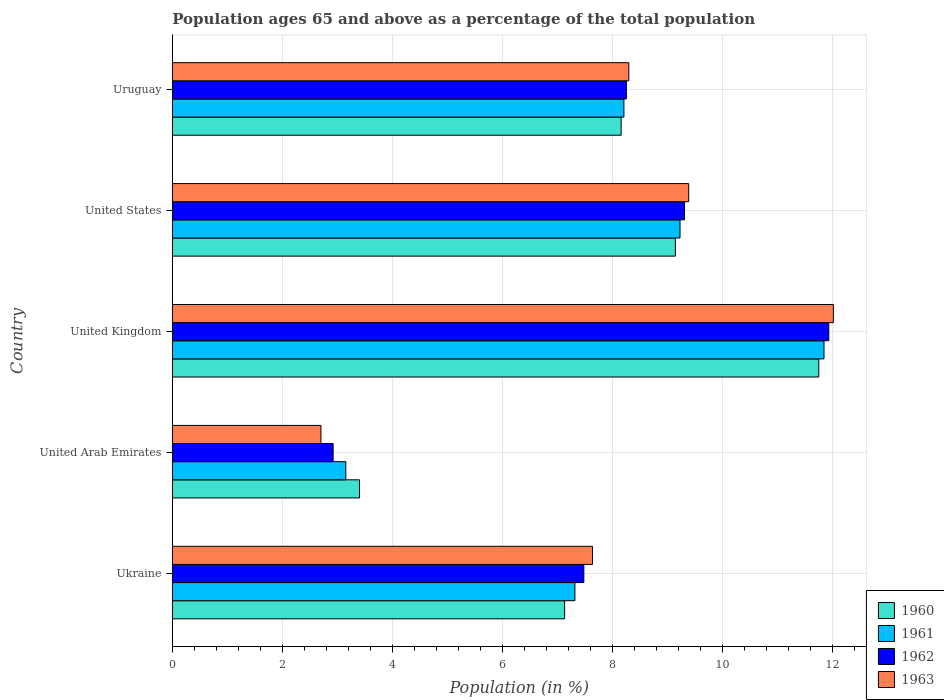How many bars are there on the 1st tick from the top?
Offer a very short reply. 4. What is the label of the 4th group of bars from the top?
Give a very brief answer. United Arab Emirates. In how many cases, is the number of bars for a given country not equal to the number of legend labels?
Your response must be concise. 0. What is the percentage of the population ages 65 and above in 1963 in United States?
Offer a terse response. 9.39. Across all countries, what is the maximum percentage of the population ages 65 and above in 1962?
Your response must be concise. 11.94. Across all countries, what is the minimum percentage of the population ages 65 and above in 1962?
Your answer should be very brief. 2.92. In which country was the percentage of the population ages 65 and above in 1961 minimum?
Keep it short and to the point. United Arab Emirates. What is the total percentage of the population ages 65 and above in 1963 in the graph?
Your answer should be very brief. 40.05. What is the difference between the percentage of the population ages 65 and above in 1962 in Ukraine and that in Uruguay?
Provide a short and direct response. -0.77. What is the difference between the percentage of the population ages 65 and above in 1961 in United States and the percentage of the population ages 65 and above in 1960 in Uruguay?
Your answer should be compact. 1.07. What is the average percentage of the population ages 65 and above in 1960 per country?
Your response must be concise. 7.92. What is the difference between the percentage of the population ages 65 and above in 1961 and percentage of the population ages 65 and above in 1962 in United States?
Provide a succinct answer. -0.08. What is the ratio of the percentage of the population ages 65 and above in 1960 in Ukraine to that in Uruguay?
Offer a very short reply. 0.87. Is the difference between the percentage of the population ages 65 and above in 1961 in Ukraine and United States greater than the difference between the percentage of the population ages 65 and above in 1962 in Ukraine and United States?
Your response must be concise. No. What is the difference between the highest and the second highest percentage of the population ages 65 and above in 1960?
Ensure brevity in your answer.  2.61. What is the difference between the highest and the lowest percentage of the population ages 65 and above in 1962?
Give a very brief answer. 9.01. What does the 1st bar from the bottom in United States represents?
Offer a very short reply. 1960. Is it the case that in every country, the sum of the percentage of the population ages 65 and above in 1963 and percentage of the population ages 65 and above in 1961 is greater than the percentage of the population ages 65 and above in 1960?
Ensure brevity in your answer.  Yes. How many countries are there in the graph?
Give a very brief answer. 5. Does the graph contain any zero values?
Your response must be concise. No. Where does the legend appear in the graph?
Your response must be concise. Bottom right. How many legend labels are there?
Give a very brief answer. 4. How are the legend labels stacked?
Offer a very short reply. Vertical. What is the title of the graph?
Your response must be concise. Population ages 65 and above as a percentage of the total population. What is the label or title of the Y-axis?
Provide a succinct answer. Country. What is the Population (in %) of 1960 in Ukraine?
Provide a short and direct response. 7.13. What is the Population (in %) of 1961 in Ukraine?
Offer a terse response. 7.32. What is the Population (in %) of 1962 in Ukraine?
Your response must be concise. 7.48. What is the Population (in %) in 1963 in Ukraine?
Give a very brief answer. 7.64. What is the Population (in %) of 1960 in United Arab Emirates?
Your answer should be compact. 3.4. What is the Population (in %) in 1961 in United Arab Emirates?
Give a very brief answer. 3.15. What is the Population (in %) in 1962 in United Arab Emirates?
Your answer should be compact. 2.92. What is the Population (in %) in 1963 in United Arab Emirates?
Make the answer very short. 2.7. What is the Population (in %) of 1960 in United Kingdom?
Your response must be concise. 11.75. What is the Population (in %) of 1961 in United Kingdom?
Provide a succinct answer. 11.85. What is the Population (in %) in 1962 in United Kingdom?
Provide a short and direct response. 11.94. What is the Population (in %) of 1963 in United Kingdom?
Your answer should be compact. 12.02. What is the Population (in %) in 1960 in United States?
Your answer should be very brief. 9.15. What is the Population (in %) in 1961 in United States?
Your answer should be compact. 9.23. What is the Population (in %) in 1962 in United States?
Offer a very short reply. 9.31. What is the Population (in %) of 1963 in United States?
Your response must be concise. 9.39. What is the Population (in %) in 1960 in Uruguay?
Your answer should be compact. 8.16. What is the Population (in %) of 1961 in Uruguay?
Keep it short and to the point. 8.21. What is the Population (in %) of 1962 in Uruguay?
Ensure brevity in your answer.  8.26. What is the Population (in %) in 1963 in Uruguay?
Provide a short and direct response. 8.3. Across all countries, what is the maximum Population (in %) in 1960?
Offer a very short reply. 11.75. Across all countries, what is the maximum Population (in %) of 1961?
Ensure brevity in your answer.  11.85. Across all countries, what is the maximum Population (in %) in 1962?
Your answer should be very brief. 11.94. Across all countries, what is the maximum Population (in %) of 1963?
Keep it short and to the point. 12.02. Across all countries, what is the minimum Population (in %) of 1960?
Provide a succinct answer. 3.4. Across all countries, what is the minimum Population (in %) in 1961?
Offer a very short reply. 3.15. Across all countries, what is the minimum Population (in %) of 1962?
Provide a short and direct response. 2.92. Across all countries, what is the minimum Population (in %) of 1963?
Give a very brief answer. 2.7. What is the total Population (in %) in 1960 in the graph?
Make the answer very short. 39.6. What is the total Population (in %) in 1961 in the graph?
Ensure brevity in your answer.  39.76. What is the total Population (in %) of 1962 in the graph?
Offer a terse response. 39.91. What is the total Population (in %) of 1963 in the graph?
Offer a very short reply. 40.05. What is the difference between the Population (in %) in 1960 in Ukraine and that in United Arab Emirates?
Your response must be concise. 3.73. What is the difference between the Population (in %) in 1961 in Ukraine and that in United Arab Emirates?
Ensure brevity in your answer.  4.17. What is the difference between the Population (in %) in 1962 in Ukraine and that in United Arab Emirates?
Provide a short and direct response. 4.56. What is the difference between the Population (in %) of 1963 in Ukraine and that in United Arab Emirates?
Provide a succinct answer. 4.94. What is the difference between the Population (in %) of 1960 in Ukraine and that in United Kingdom?
Your response must be concise. -4.62. What is the difference between the Population (in %) in 1961 in Ukraine and that in United Kingdom?
Provide a short and direct response. -4.53. What is the difference between the Population (in %) in 1962 in Ukraine and that in United Kingdom?
Keep it short and to the point. -4.45. What is the difference between the Population (in %) in 1963 in Ukraine and that in United Kingdom?
Give a very brief answer. -4.38. What is the difference between the Population (in %) of 1960 in Ukraine and that in United States?
Provide a succinct answer. -2.01. What is the difference between the Population (in %) in 1961 in Ukraine and that in United States?
Your answer should be very brief. -1.91. What is the difference between the Population (in %) in 1962 in Ukraine and that in United States?
Make the answer very short. -1.83. What is the difference between the Population (in %) in 1963 in Ukraine and that in United States?
Make the answer very short. -1.75. What is the difference between the Population (in %) in 1960 in Ukraine and that in Uruguay?
Provide a succinct answer. -1.03. What is the difference between the Population (in %) in 1961 in Ukraine and that in Uruguay?
Make the answer very short. -0.89. What is the difference between the Population (in %) of 1962 in Ukraine and that in Uruguay?
Your response must be concise. -0.77. What is the difference between the Population (in %) of 1963 in Ukraine and that in Uruguay?
Your response must be concise. -0.66. What is the difference between the Population (in %) of 1960 in United Arab Emirates and that in United Kingdom?
Offer a very short reply. -8.35. What is the difference between the Population (in %) in 1961 in United Arab Emirates and that in United Kingdom?
Ensure brevity in your answer.  -8.69. What is the difference between the Population (in %) in 1962 in United Arab Emirates and that in United Kingdom?
Offer a very short reply. -9.01. What is the difference between the Population (in %) of 1963 in United Arab Emirates and that in United Kingdom?
Offer a very short reply. -9.32. What is the difference between the Population (in %) of 1960 in United Arab Emirates and that in United States?
Give a very brief answer. -5.74. What is the difference between the Population (in %) in 1961 in United Arab Emirates and that in United States?
Provide a succinct answer. -6.08. What is the difference between the Population (in %) in 1962 in United Arab Emirates and that in United States?
Your answer should be compact. -6.39. What is the difference between the Population (in %) of 1963 in United Arab Emirates and that in United States?
Offer a very short reply. -6.69. What is the difference between the Population (in %) in 1960 in United Arab Emirates and that in Uruguay?
Keep it short and to the point. -4.76. What is the difference between the Population (in %) in 1961 in United Arab Emirates and that in Uruguay?
Make the answer very short. -5.06. What is the difference between the Population (in %) in 1962 in United Arab Emirates and that in Uruguay?
Give a very brief answer. -5.33. What is the difference between the Population (in %) of 1963 in United Arab Emirates and that in Uruguay?
Your answer should be compact. -5.6. What is the difference between the Population (in %) in 1960 in United Kingdom and that in United States?
Your response must be concise. 2.61. What is the difference between the Population (in %) in 1961 in United Kingdom and that in United States?
Your response must be concise. 2.62. What is the difference between the Population (in %) in 1962 in United Kingdom and that in United States?
Offer a terse response. 2.62. What is the difference between the Population (in %) in 1963 in United Kingdom and that in United States?
Provide a short and direct response. 2.63. What is the difference between the Population (in %) in 1960 in United Kingdom and that in Uruguay?
Ensure brevity in your answer.  3.59. What is the difference between the Population (in %) of 1961 in United Kingdom and that in Uruguay?
Keep it short and to the point. 3.64. What is the difference between the Population (in %) of 1962 in United Kingdom and that in Uruguay?
Give a very brief answer. 3.68. What is the difference between the Population (in %) in 1963 in United Kingdom and that in Uruguay?
Offer a very short reply. 3.72. What is the difference between the Population (in %) of 1960 in United States and that in Uruguay?
Your response must be concise. 0.99. What is the difference between the Population (in %) in 1961 in United States and that in Uruguay?
Offer a terse response. 1.02. What is the difference between the Population (in %) in 1962 in United States and that in Uruguay?
Your response must be concise. 1.06. What is the difference between the Population (in %) in 1963 in United States and that in Uruguay?
Your answer should be very brief. 1.09. What is the difference between the Population (in %) in 1960 in Ukraine and the Population (in %) in 1961 in United Arab Emirates?
Your answer should be compact. 3.98. What is the difference between the Population (in %) of 1960 in Ukraine and the Population (in %) of 1962 in United Arab Emirates?
Your response must be concise. 4.21. What is the difference between the Population (in %) in 1960 in Ukraine and the Population (in %) in 1963 in United Arab Emirates?
Offer a terse response. 4.43. What is the difference between the Population (in %) of 1961 in Ukraine and the Population (in %) of 1962 in United Arab Emirates?
Provide a short and direct response. 4.4. What is the difference between the Population (in %) in 1961 in Ukraine and the Population (in %) in 1963 in United Arab Emirates?
Ensure brevity in your answer.  4.62. What is the difference between the Population (in %) of 1962 in Ukraine and the Population (in %) of 1963 in United Arab Emirates?
Your response must be concise. 4.78. What is the difference between the Population (in %) in 1960 in Ukraine and the Population (in %) in 1961 in United Kingdom?
Your answer should be compact. -4.72. What is the difference between the Population (in %) of 1960 in Ukraine and the Population (in %) of 1962 in United Kingdom?
Make the answer very short. -4.8. What is the difference between the Population (in %) of 1960 in Ukraine and the Population (in %) of 1963 in United Kingdom?
Make the answer very short. -4.89. What is the difference between the Population (in %) of 1961 in Ukraine and the Population (in %) of 1962 in United Kingdom?
Keep it short and to the point. -4.62. What is the difference between the Population (in %) of 1961 in Ukraine and the Population (in %) of 1963 in United Kingdom?
Offer a very short reply. -4.7. What is the difference between the Population (in %) in 1962 in Ukraine and the Population (in %) in 1963 in United Kingdom?
Your response must be concise. -4.54. What is the difference between the Population (in %) in 1960 in Ukraine and the Population (in %) in 1961 in United States?
Your answer should be very brief. -2.1. What is the difference between the Population (in %) of 1960 in Ukraine and the Population (in %) of 1962 in United States?
Offer a terse response. -2.18. What is the difference between the Population (in %) in 1960 in Ukraine and the Population (in %) in 1963 in United States?
Your answer should be compact. -2.26. What is the difference between the Population (in %) in 1961 in Ukraine and the Population (in %) in 1962 in United States?
Your answer should be very brief. -1.99. What is the difference between the Population (in %) of 1961 in Ukraine and the Population (in %) of 1963 in United States?
Keep it short and to the point. -2.07. What is the difference between the Population (in %) of 1962 in Ukraine and the Population (in %) of 1963 in United States?
Provide a short and direct response. -1.91. What is the difference between the Population (in %) of 1960 in Ukraine and the Population (in %) of 1961 in Uruguay?
Your answer should be compact. -1.08. What is the difference between the Population (in %) of 1960 in Ukraine and the Population (in %) of 1962 in Uruguay?
Make the answer very short. -1.12. What is the difference between the Population (in %) of 1960 in Ukraine and the Population (in %) of 1963 in Uruguay?
Offer a terse response. -1.17. What is the difference between the Population (in %) of 1961 in Ukraine and the Population (in %) of 1962 in Uruguay?
Provide a succinct answer. -0.94. What is the difference between the Population (in %) of 1961 in Ukraine and the Population (in %) of 1963 in Uruguay?
Give a very brief answer. -0.98. What is the difference between the Population (in %) in 1962 in Ukraine and the Population (in %) in 1963 in Uruguay?
Offer a very short reply. -0.82. What is the difference between the Population (in %) in 1960 in United Arab Emirates and the Population (in %) in 1961 in United Kingdom?
Provide a succinct answer. -8.45. What is the difference between the Population (in %) of 1960 in United Arab Emirates and the Population (in %) of 1962 in United Kingdom?
Keep it short and to the point. -8.53. What is the difference between the Population (in %) in 1960 in United Arab Emirates and the Population (in %) in 1963 in United Kingdom?
Provide a short and direct response. -8.62. What is the difference between the Population (in %) of 1961 in United Arab Emirates and the Population (in %) of 1962 in United Kingdom?
Offer a very short reply. -8.78. What is the difference between the Population (in %) of 1961 in United Arab Emirates and the Population (in %) of 1963 in United Kingdom?
Make the answer very short. -8.86. What is the difference between the Population (in %) in 1962 in United Arab Emirates and the Population (in %) in 1963 in United Kingdom?
Make the answer very short. -9.1. What is the difference between the Population (in %) of 1960 in United Arab Emirates and the Population (in %) of 1961 in United States?
Keep it short and to the point. -5.83. What is the difference between the Population (in %) in 1960 in United Arab Emirates and the Population (in %) in 1962 in United States?
Provide a succinct answer. -5.91. What is the difference between the Population (in %) in 1960 in United Arab Emirates and the Population (in %) in 1963 in United States?
Give a very brief answer. -5.98. What is the difference between the Population (in %) in 1961 in United Arab Emirates and the Population (in %) in 1962 in United States?
Your answer should be very brief. -6.16. What is the difference between the Population (in %) in 1961 in United Arab Emirates and the Population (in %) in 1963 in United States?
Give a very brief answer. -6.23. What is the difference between the Population (in %) of 1962 in United Arab Emirates and the Population (in %) of 1963 in United States?
Your answer should be very brief. -6.46. What is the difference between the Population (in %) of 1960 in United Arab Emirates and the Population (in %) of 1961 in Uruguay?
Make the answer very short. -4.81. What is the difference between the Population (in %) in 1960 in United Arab Emirates and the Population (in %) in 1962 in Uruguay?
Offer a very short reply. -4.85. What is the difference between the Population (in %) in 1960 in United Arab Emirates and the Population (in %) in 1963 in Uruguay?
Your response must be concise. -4.9. What is the difference between the Population (in %) in 1961 in United Arab Emirates and the Population (in %) in 1962 in Uruguay?
Your response must be concise. -5.1. What is the difference between the Population (in %) of 1961 in United Arab Emirates and the Population (in %) of 1963 in Uruguay?
Make the answer very short. -5.15. What is the difference between the Population (in %) in 1962 in United Arab Emirates and the Population (in %) in 1963 in Uruguay?
Make the answer very short. -5.38. What is the difference between the Population (in %) in 1960 in United Kingdom and the Population (in %) in 1961 in United States?
Give a very brief answer. 2.52. What is the difference between the Population (in %) of 1960 in United Kingdom and the Population (in %) of 1962 in United States?
Offer a very short reply. 2.44. What is the difference between the Population (in %) of 1960 in United Kingdom and the Population (in %) of 1963 in United States?
Ensure brevity in your answer.  2.37. What is the difference between the Population (in %) of 1961 in United Kingdom and the Population (in %) of 1962 in United States?
Give a very brief answer. 2.54. What is the difference between the Population (in %) of 1961 in United Kingdom and the Population (in %) of 1963 in United States?
Your answer should be very brief. 2.46. What is the difference between the Population (in %) of 1962 in United Kingdom and the Population (in %) of 1963 in United States?
Your response must be concise. 2.55. What is the difference between the Population (in %) of 1960 in United Kingdom and the Population (in %) of 1961 in Uruguay?
Give a very brief answer. 3.54. What is the difference between the Population (in %) of 1960 in United Kingdom and the Population (in %) of 1962 in Uruguay?
Offer a very short reply. 3.5. What is the difference between the Population (in %) of 1960 in United Kingdom and the Population (in %) of 1963 in Uruguay?
Your answer should be compact. 3.45. What is the difference between the Population (in %) of 1961 in United Kingdom and the Population (in %) of 1962 in Uruguay?
Ensure brevity in your answer.  3.59. What is the difference between the Population (in %) of 1961 in United Kingdom and the Population (in %) of 1963 in Uruguay?
Keep it short and to the point. 3.55. What is the difference between the Population (in %) in 1962 in United Kingdom and the Population (in %) in 1963 in Uruguay?
Your answer should be very brief. 3.64. What is the difference between the Population (in %) in 1960 in United States and the Population (in %) in 1961 in Uruguay?
Your answer should be compact. 0.94. What is the difference between the Population (in %) in 1960 in United States and the Population (in %) in 1962 in Uruguay?
Offer a terse response. 0.89. What is the difference between the Population (in %) in 1960 in United States and the Population (in %) in 1963 in Uruguay?
Your answer should be compact. 0.85. What is the difference between the Population (in %) in 1961 in United States and the Population (in %) in 1963 in Uruguay?
Make the answer very short. 0.93. What is the difference between the Population (in %) in 1962 in United States and the Population (in %) in 1963 in Uruguay?
Provide a short and direct response. 1.01. What is the average Population (in %) of 1960 per country?
Ensure brevity in your answer.  7.92. What is the average Population (in %) of 1961 per country?
Offer a terse response. 7.95. What is the average Population (in %) in 1962 per country?
Your answer should be very brief. 7.98. What is the average Population (in %) in 1963 per country?
Your answer should be compact. 8.01. What is the difference between the Population (in %) of 1960 and Population (in %) of 1961 in Ukraine?
Offer a very short reply. -0.19. What is the difference between the Population (in %) in 1960 and Population (in %) in 1962 in Ukraine?
Offer a very short reply. -0.35. What is the difference between the Population (in %) of 1960 and Population (in %) of 1963 in Ukraine?
Your answer should be very brief. -0.51. What is the difference between the Population (in %) in 1961 and Population (in %) in 1962 in Ukraine?
Your answer should be compact. -0.16. What is the difference between the Population (in %) in 1961 and Population (in %) in 1963 in Ukraine?
Provide a succinct answer. -0.32. What is the difference between the Population (in %) in 1962 and Population (in %) in 1963 in Ukraine?
Make the answer very short. -0.16. What is the difference between the Population (in %) of 1960 and Population (in %) of 1961 in United Arab Emirates?
Provide a short and direct response. 0.25. What is the difference between the Population (in %) in 1960 and Population (in %) in 1962 in United Arab Emirates?
Offer a terse response. 0.48. What is the difference between the Population (in %) in 1960 and Population (in %) in 1963 in United Arab Emirates?
Your answer should be compact. 0.7. What is the difference between the Population (in %) in 1961 and Population (in %) in 1962 in United Arab Emirates?
Provide a short and direct response. 0.23. What is the difference between the Population (in %) in 1961 and Population (in %) in 1963 in United Arab Emirates?
Provide a short and direct response. 0.45. What is the difference between the Population (in %) in 1962 and Population (in %) in 1963 in United Arab Emirates?
Give a very brief answer. 0.22. What is the difference between the Population (in %) in 1960 and Population (in %) in 1961 in United Kingdom?
Your answer should be compact. -0.09. What is the difference between the Population (in %) of 1960 and Population (in %) of 1962 in United Kingdom?
Give a very brief answer. -0.18. What is the difference between the Population (in %) of 1960 and Population (in %) of 1963 in United Kingdom?
Give a very brief answer. -0.27. What is the difference between the Population (in %) of 1961 and Population (in %) of 1962 in United Kingdom?
Give a very brief answer. -0.09. What is the difference between the Population (in %) of 1961 and Population (in %) of 1963 in United Kingdom?
Make the answer very short. -0.17. What is the difference between the Population (in %) in 1962 and Population (in %) in 1963 in United Kingdom?
Ensure brevity in your answer.  -0.08. What is the difference between the Population (in %) in 1960 and Population (in %) in 1961 in United States?
Offer a very short reply. -0.08. What is the difference between the Population (in %) of 1960 and Population (in %) of 1962 in United States?
Keep it short and to the point. -0.17. What is the difference between the Population (in %) in 1960 and Population (in %) in 1963 in United States?
Give a very brief answer. -0.24. What is the difference between the Population (in %) of 1961 and Population (in %) of 1962 in United States?
Offer a terse response. -0.08. What is the difference between the Population (in %) in 1961 and Population (in %) in 1963 in United States?
Offer a very short reply. -0.16. What is the difference between the Population (in %) of 1962 and Population (in %) of 1963 in United States?
Your answer should be compact. -0.08. What is the difference between the Population (in %) of 1960 and Population (in %) of 1961 in Uruguay?
Ensure brevity in your answer.  -0.05. What is the difference between the Population (in %) in 1960 and Population (in %) in 1962 in Uruguay?
Offer a very short reply. -0.1. What is the difference between the Population (in %) in 1960 and Population (in %) in 1963 in Uruguay?
Give a very brief answer. -0.14. What is the difference between the Population (in %) of 1961 and Population (in %) of 1962 in Uruguay?
Give a very brief answer. -0.05. What is the difference between the Population (in %) of 1961 and Population (in %) of 1963 in Uruguay?
Provide a succinct answer. -0.09. What is the difference between the Population (in %) of 1962 and Population (in %) of 1963 in Uruguay?
Offer a terse response. -0.04. What is the ratio of the Population (in %) in 1960 in Ukraine to that in United Arab Emirates?
Your answer should be very brief. 2.1. What is the ratio of the Population (in %) in 1961 in Ukraine to that in United Arab Emirates?
Keep it short and to the point. 2.32. What is the ratio of the Population (in %) in 1962 in Ukraine to that in United Arab Emirates?
Keep it short and to the point. 2.56. What is the ratio of the Population (in %) of 1963 in Ukraine to that in United Arab Emirates?
Provide a succinct answer. 2.83. What is the ratio of the Population (in %) in 1960 in Ukraine to that in United Kingdom?
Your answer should be compact. 0.61. What is the ratio of the Population (in %) in 1961 in Ukraine to that in United Kingdom?
Give a very brief answer. 0.62. What is the ratio of the Population (in %) in 1962 in Ukraine to that in United Kingdom?
Make the answer very short. 0.63. What is the ratio of the Population (in %) in 1963 in Ukraine to that in United Kingdom?
Provide a short and direct response. 0.64. What is the ratio of the Population (in %) in 1960 in Ukraine to that in United States?
Keep it short and to the point. 0.78. What is the ratio of the Population (in %) in 1961 in Ukraine to that in United States?
Make the answer very short. 0.79. What is the ratio of the Population (in %) of 1962 in Ukraine to that in United States?
Offer a terse response. 0.8. What is the ratio of the Population (in %) of 1963 in Ukraine to that in United States?
Provide a short and direct response. 0.81. What is the ratio of the Population (in %) of 1960 in Ukraine to that in Uruguay?
Your response must be concise. 0.87. What is the ratio of the Population (in %) in 1961 in Ukraine to that in Uruguay?
Your answer should be very brief. 0.89. What is the ratio of the Population (in %) in 1962 in Ukraine to that in Uruguay?
Your response must be concise. 0.91. What is the ratio of the Population (in %) in 1963 in Ukraine to that in Uruguay?
Offer a terse response. 0.92. What is the ratio of the Population (in %) in 1960 in United Arab Emirates to that in United Kingdom?
Ensure brevity in your answer.  0.29. What is the ratio of the Population (in %) in 1961 in United Arab Emirates to that in United Kingdom?
Your answer should be compact. 0.27. What is the ratio of the Population (in %) in 1962 in United Arab Emirates to that in United Kingdom?
Make the answer very short. 0.24. What is the ratio of the Population (in %) of 1963 in United Arab Emirates to that in United Kingdom?
Your response must be concise. 0.22. What is the ratio of the Population (in %) in 1960 in United Arab Emirates to that in United States?
Your answer should be compact. 0.37. What is the ratio of the Population (in %) of 1961 in United Arab Emirates to that in United States?
Give a very brief answer. 0.34. What is the ratio of the Population (in %) of 1962 in United Arab Emirates to that in United States?
Provide a succinct answer. 0.31. What is the ratio of the Population (in %) in 1963 in United Arab Emirates to that in United States?
Ensure brevity in your answer.  0.29. What is the ratio of the Population (in %) in 1960 in United Arab Emirates to that in Uruguay?
Offer a terse response. 0.42. What is the ratio of the Population (in %) of 1961 in United Arab Emirates to that in Uruguay?
Give a very brief answer. 0.38. What is the ratio of the Population (in %) in 1962 in United Arab Emirates to that in Uruguay?
Give a very brief answer. 0.35. What is the ratio of the Population (in %) in 1963 in United Arab Emirates to that in Uruguay?
Ensure brevity in your answer.  0.33. What is the ratio of the Population (in %) of 1960 in United Kingdom to that in United States?
Make the answer very short. 1.29. What is the ratio of the Population (in %) of 1961 in United Kingdom to that in United States?
Provide a succinct answer. 1.28. What is the ratio of the Population (in %) in 1962 in United Kingdom to that in United States?
Your answer should be compact. 1.28. What is the ratio of the Population (in %) of 1963 in United Kingdom to that in United States?
Provide a succinct answer. 1.28. What is the ratio of the Population (in %) in 1960 in United Kingdom to that in Uruguay?
Offer a very short reply. 1.44. What is the ratio of the Population (in %) in 1961 in United Kingdom to that in Uruguay?
Provide a short and direct response. 1.44. What is the ratio of the Population (in %) in 1962 in United Kingdom to that in Uruguay?
Ensure brevity in your answer.  1.45. What is the ratio of the Population (in %) of 1963 in United Kingdom to that in Uruguay?
Provide a short and direct response. 1.45. What is the ratio of the Population (in %) in 1960 in United States to that in Uruguay?
Offer a very short reply. 1.12. What is the ratio of the Population (in %) of 1961 in United States to that in Uruguay?
Your answer should be very brief. 1.12. What is the ratio of the Population (in %) of 1962 in United States to that in Uruguay?
Your answer should be compact. 1.13. What is the ratio of the Population (in %) in 1963 in United States to that in Uruguay?
Offer a terse response. 1.13. What is the difference between the highest and the second highest Population (in %) in 1960?
Your answer should be very brief. 2.61. What is the difference between the highest and the second highest Population (in %) of 1961?
Your response must be concise. 2.62. What is the difference between the highest and the second highest Population (in %) of 1962?
Your response must be concise. 2.62. What is the difference between the highest and the second highest Population (in %) in 1963?
Provide a succinct answer. 2.63. What is the difference between the highest and the lowest Population (in %) in 1960?
Offer a very short reply. 8.35. What is the difference between the highest and the lowest Population (in %) in 1961?
Your answer should be compact. 8.69. What is the difference between the highest and the lowest Population (in %) in 1962?
Keep it short and to the point. 9.01. What is the difference between the highest and the lowest Population (in %) in 1963?
Make the answer very short. 9.32. 